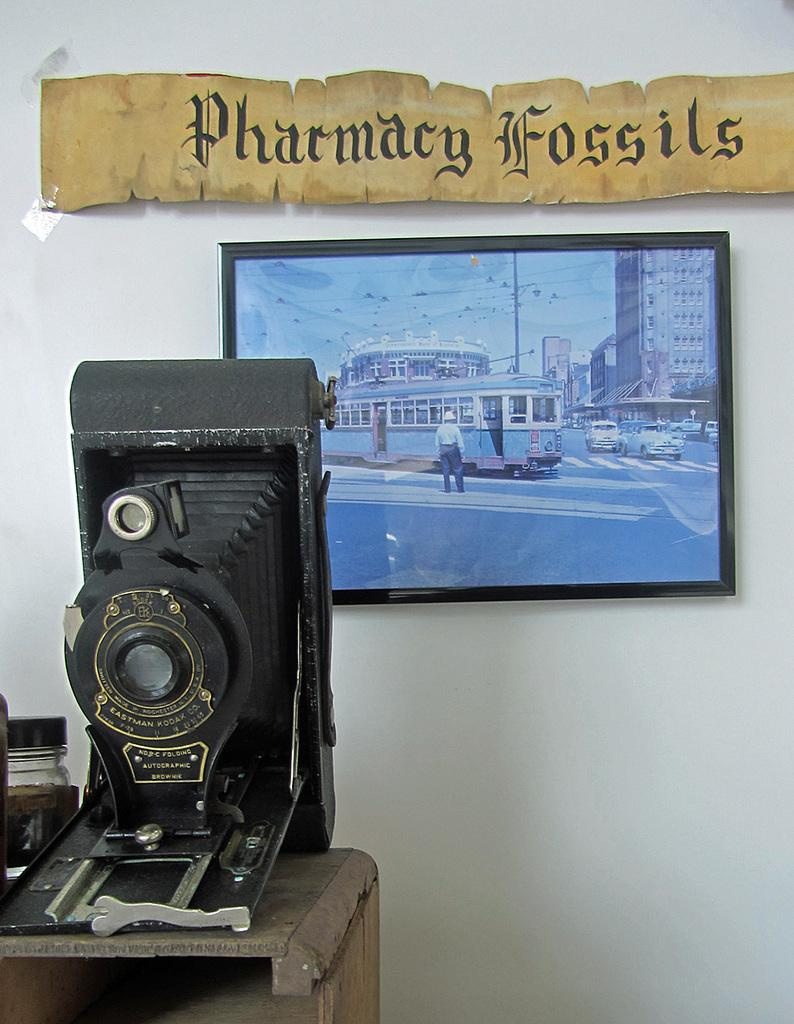What object is the main subject of the image? There is a camera in the image. What is the camera positioned in front of? The camera is positioned in front of a frame. What can be seen inside the frame? The frame contains a person, vehicles, a pole, and buildings. What is visible in the background of the image? There is a wall in the background of the image. Reasoning: Let's think step by breaking down the image step by step. We start by identifying the main subject, which is the camera. Then, we describe what the camera is positioned in front of, which is a frame. Next, we list the contents of the frame, which include a person, vehicles, a pole, and buildings. Finally, we mention the wall visible in the background of the image. Absurd Question/Answer: Can you hear the chickens in the image? There are no chickens present in the image, so it is not possible to hear them. 